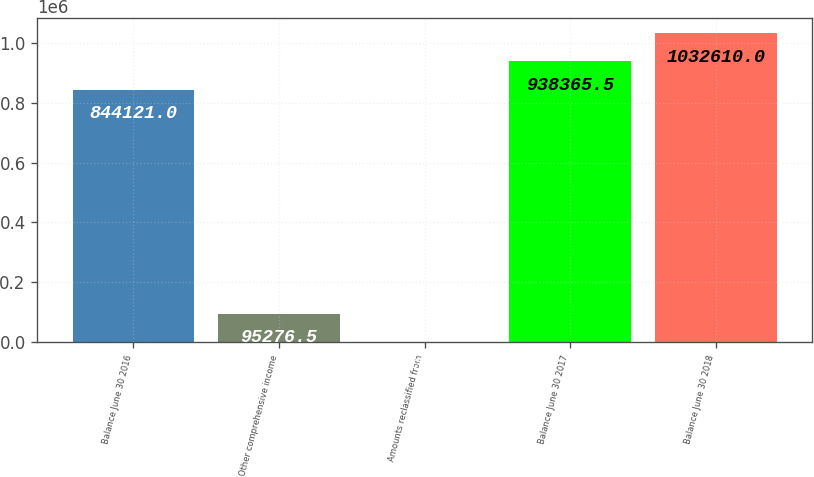<chart> <loc_0><loc_0><loc_500><loc_500><bar_chart><fcel>Balance June 30 2016<fcel>Other comprehensive income<fcel>Amounts reclassified from<fcel>Balance June 30 2017<fcel>Balance June 30 2018<nl><fcel>844121<fcel>95276.5<fcel>1032<fcel>938366<fcel>1.03261e+06<nl></chart> 